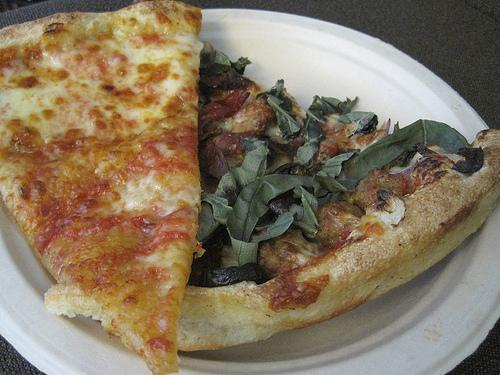Question: how many slices of pizza are there?
Choices:
A. Two.
B. Five.
C. Seven.
D. Six.
Answer with the letter. Answer: A Question: how many plates are there?
Choices:
A. Ten.
B. Eleven.
C. One.
D. Twelve.
Answer with the letter. Answer: C Question: what is the color of the plate?
Choices:
A. White.
B. Blue.
C. Yellow.
D. Gray.
Answer with the letter. Answer: A Question: where is the lettuce?
Choices:
A. Right pizza slice.
B. Under the meat.
C. In the bowl.
D. On the sandwich.
Answer with the letter. Answer: A Question: what kind of pizza is the left slice?
Choices:
A. Cheese.
B. Meat combo.
C. Veggie combo.
D. Pepperoni.
Answer with the letter. Answer: A 